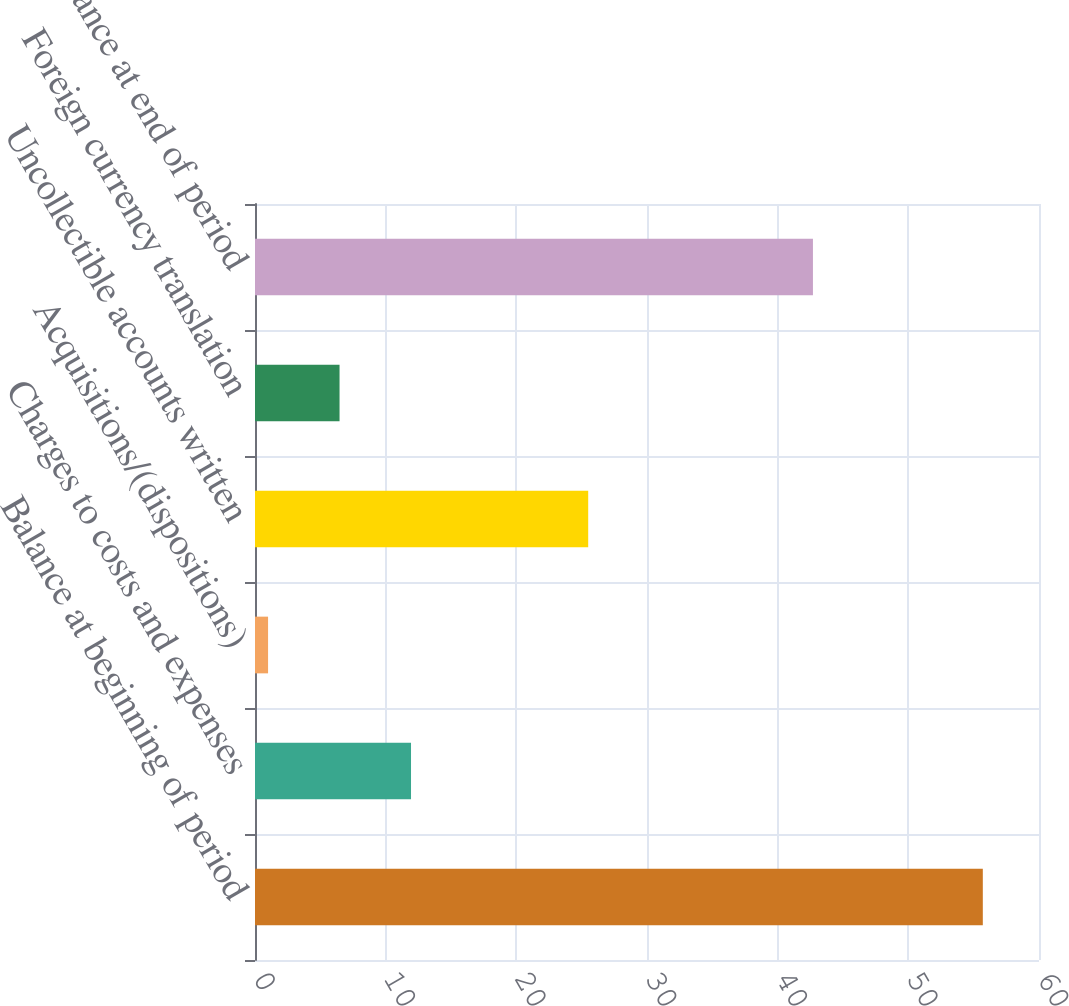Convert chart to OTSL. <chart><loc_0><loc_0><loc_500><loc_500><bar_chart><fcel>Balance at beginning of period<fcel>Charges to costs and expenses<fcel>Acquisitions/(dispositions)<fcel>Uncollectible accounts written<fcel>Foreign currency translation<fcel>Balance at end of period<nl><fcel>55.7<fcel>11.94<fcel>1<fcel>25.5<fcel>6.47<fcel>42.7<nl></chart> 